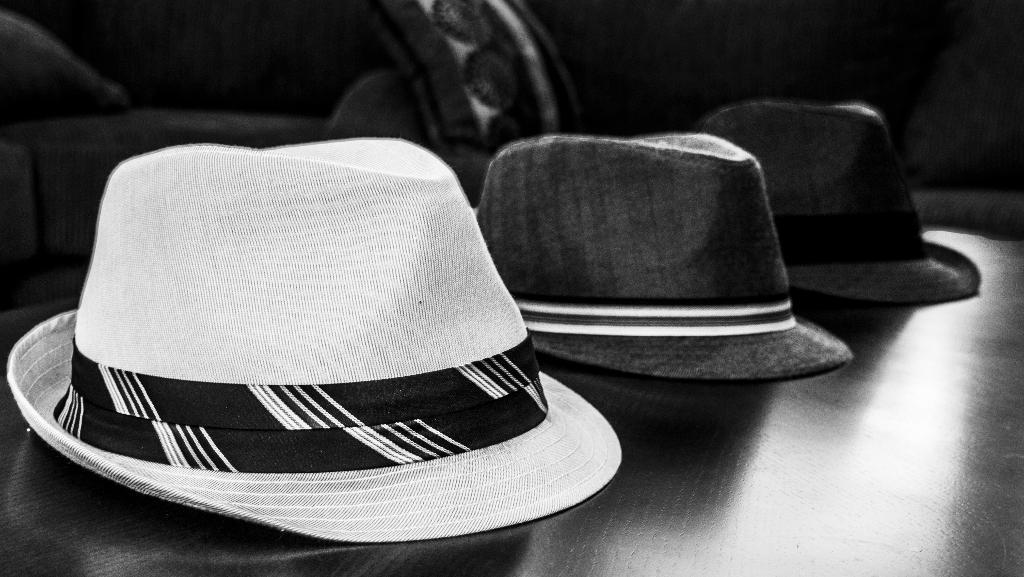How many hats are visible in the image? There are three hats in the image. Where are the hats located in the image? The hats are on a surface in the image. What type of fruit is being used as a crib for the hats in the image? There is no fruit or crib present in the image; the hats are simply on a surface. 